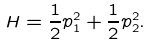Convert formula to latex. <formula><loc_0><loc_0><loc_500><loc_500>H = \frac { 1 } { 2 } p _ { 1 } ^ { 2 } + \frac { 1 } { 2 } p _ { 2 } ^ { 2 } .</formula> 